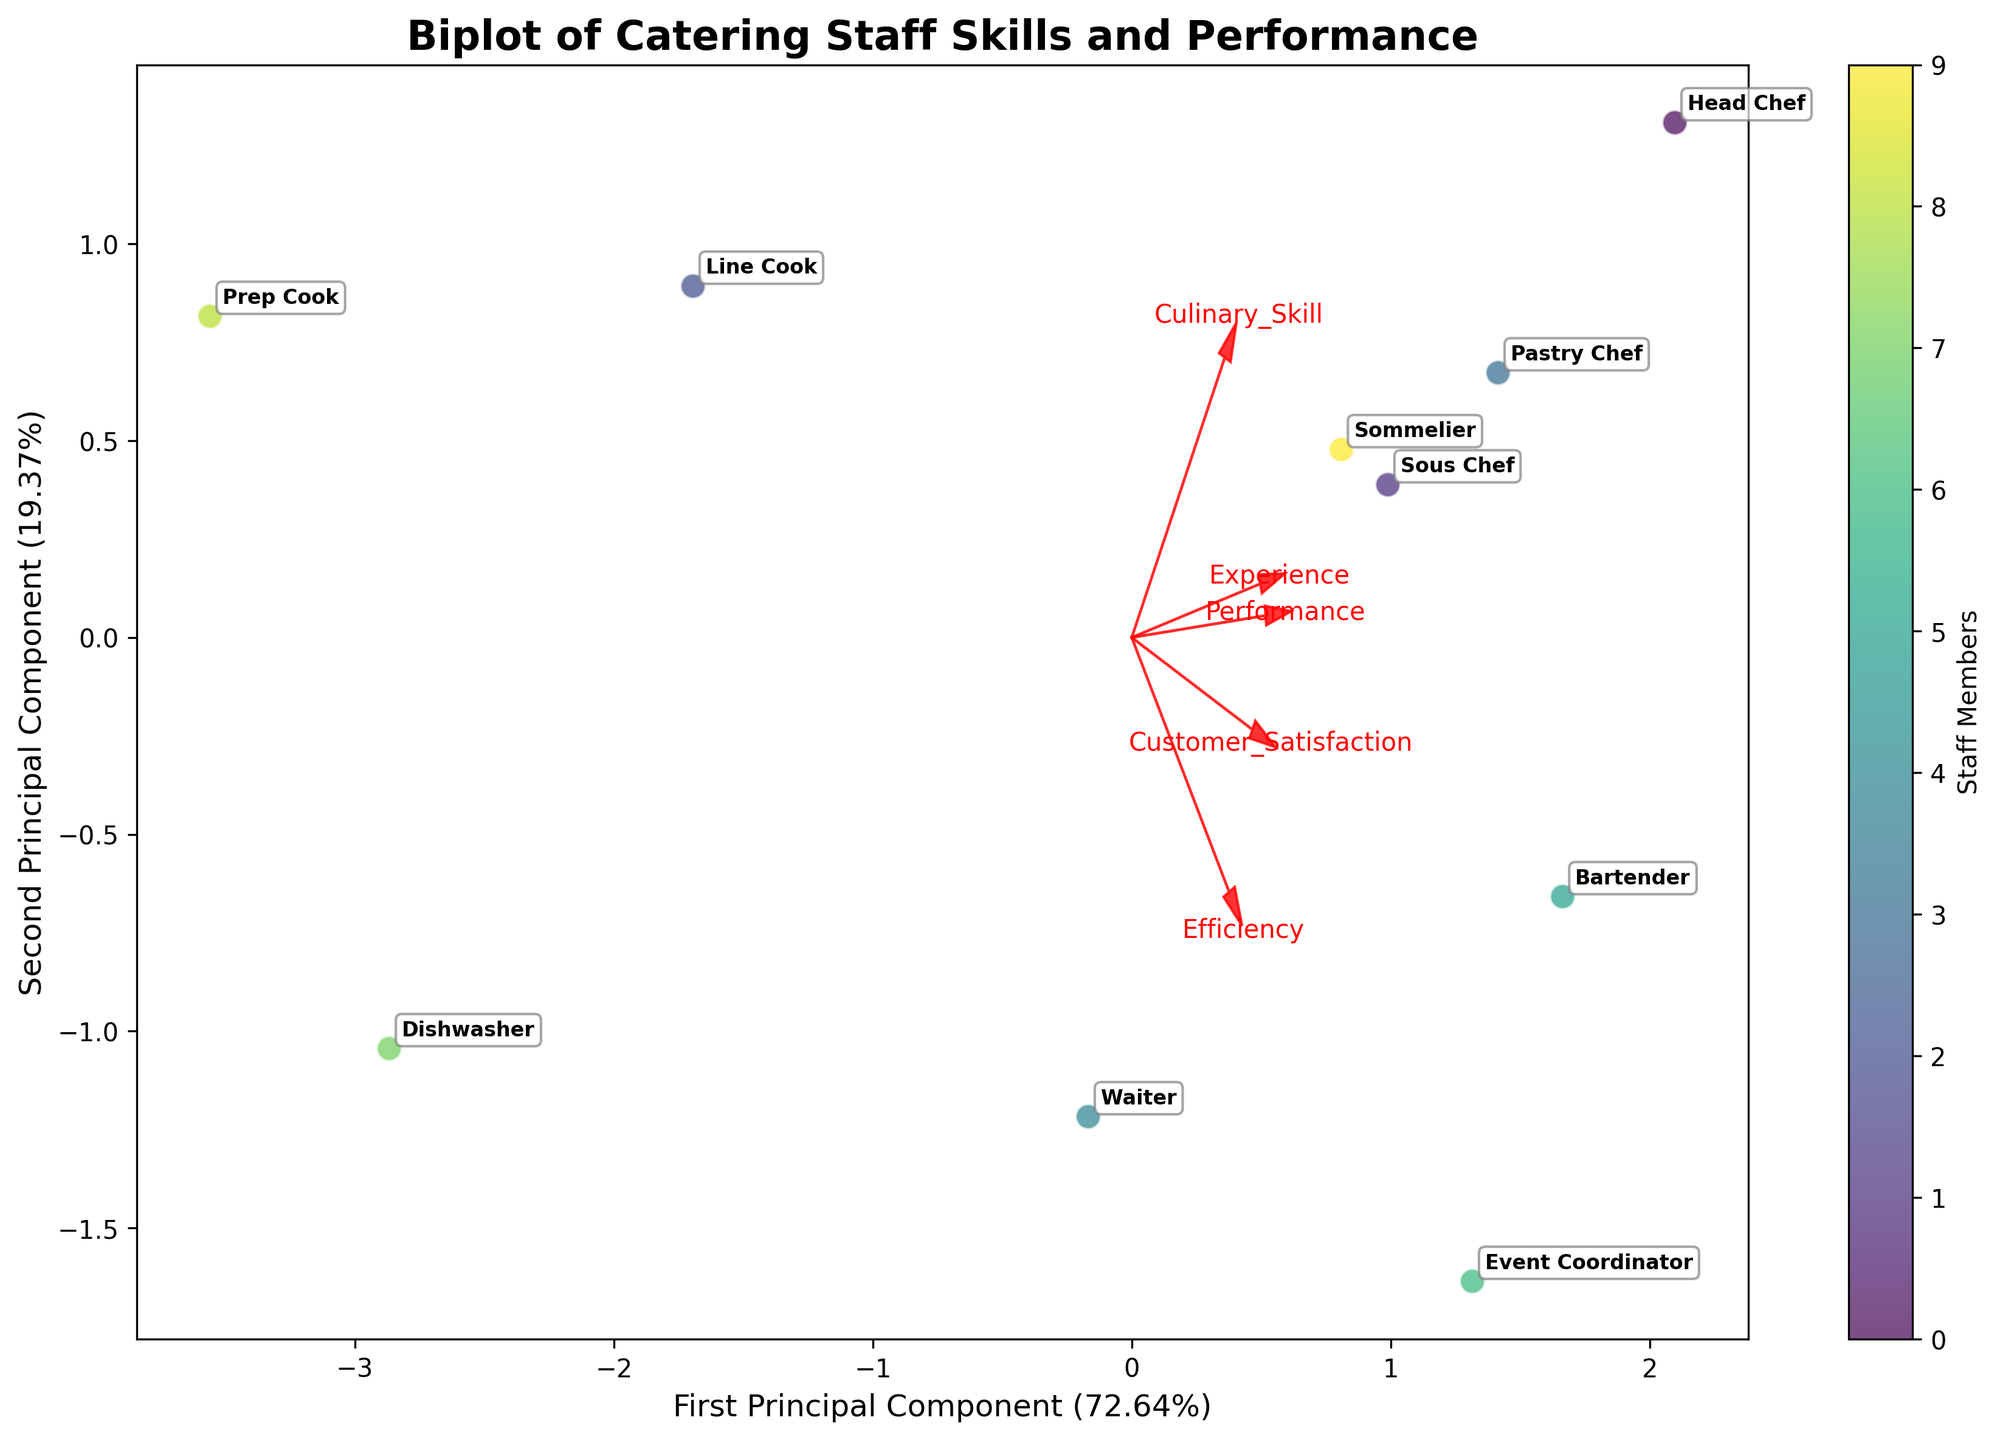Which role has the highest Performance rating? Observing the locations of the points representing different roles on the biplot, we see the Head Chef is positioned furthest along the Performance axis.
Answer: Head Chef Which feature vector has the longest arrow in the plot? The length of the arrows represents the contribution of each feature to the principal components. The Culinary_Skill vector has the longest arrow.
Answer: Culinary_Skill Which two roles have the closest positions in the plot? By examining the scatter plot, it is evident that the Waiter and Event Coordinator are positioned closest to each other.
Answer: Waiter and Event Coordinator How much of the total variance is explained by the first principal component? The x-axis label indicates the explained variance percentage of the first principal component. It shows 44.97%.
Answer: 44.97% Which role has the lowest Culinary_Skill according to the plot? Observing the positions relative to the Culinary_Skill arrow, the Dishwasher is located farthest in the opposite direction, indicating the lowest skill.
Answer: Dishwasher Which feature is most correlated with the second principal component? The arrow pointing most along the y-axis represents the feature most correlated with the second principal component. Customer_Satisfaction is closest to this direction.
Answer: Customer_Satisfaction Compare the Experience levels of the Line Cook and the Bartender. Which one has more experience? Examining the positions relative to the Experience arrow, the Bartender is positioned farther along the Experience direction than the Line Cook.
Answer: Bartender How is Efficiency associated with the first two principal components? The direction and length of the Efficiency arrow indicate its relationship with the principal components. Efficiency shows a moderate association with both components and points diagonally upwards.
Answer: Moderate association with both components Identify the role with the highest Customer_Satisfaction. The role aligned furthest along the Customer_Satisfaction arrow is the Event Coordinator.
Answer: Event Coordinator Which role has the smallest contribution to the first principal component? By assessing the location of points along the first principal component axis, the Prep Cook has the smallest contribution.
Answer: Prep Cook 